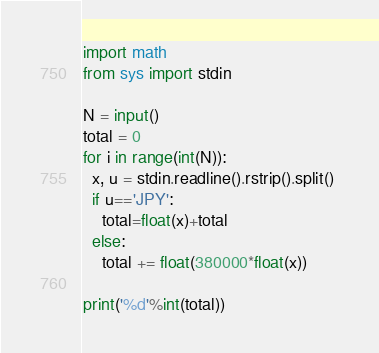Convert code to text. <code><loc_0><loc_0><loc_500><loc_500><_Python_>import math
from sys import stdin

N = input()
total = 0
for i in range(int(N)):
  x, u = stdin.readline().rstrip().split() 
  if u=='JPY':
    total=float(x)+total
  else:
    total += float(380000*float(x))
      
print('%d'%int(total))</code> 